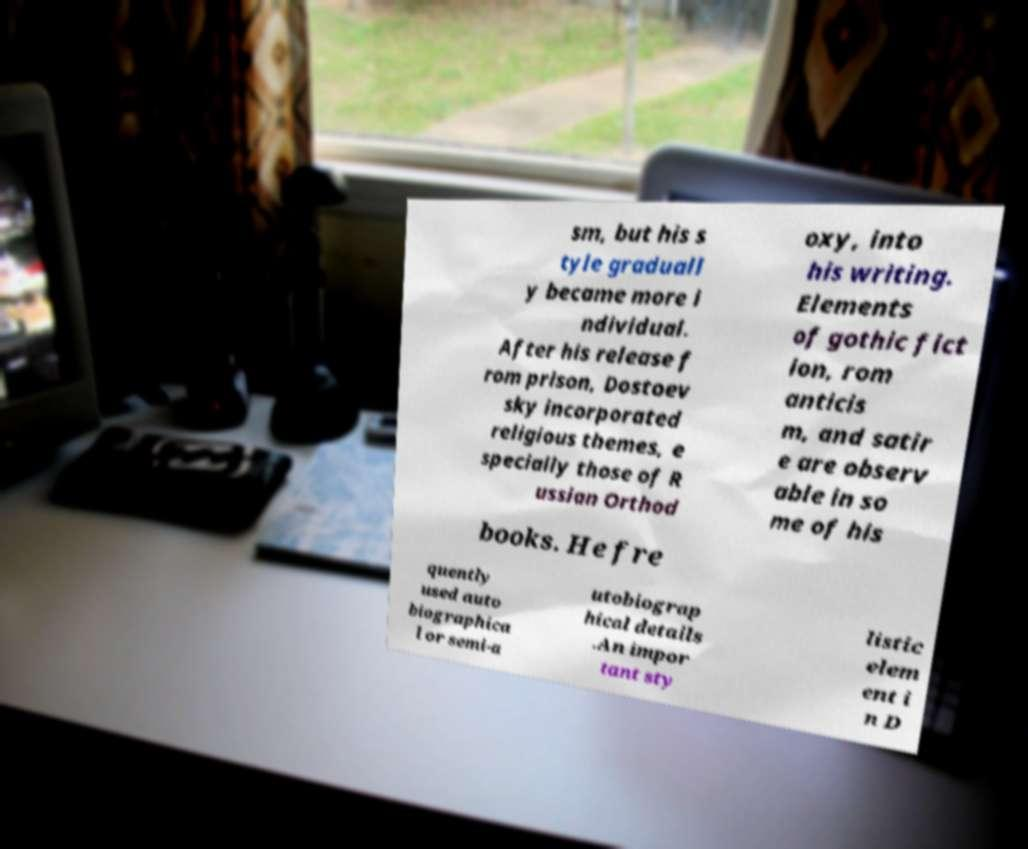Can you read and provide the text displayed in the image?This photo seems to have some interesting text. Can you extract and type it out for me? sm, but his s tyle graduall y became more i ndividual. After his release f rom prison, Dostoev sky incorporated religious themes, e specially those of R ussian Orthod oxy, into his writing. Elements of gothic fict ion, rom anticis m, and satir e are observ able in so me of his books. He fre quently used auto biographica l or semi-a utobiograp hical details .An impor tant sty listic elem ent i n D 